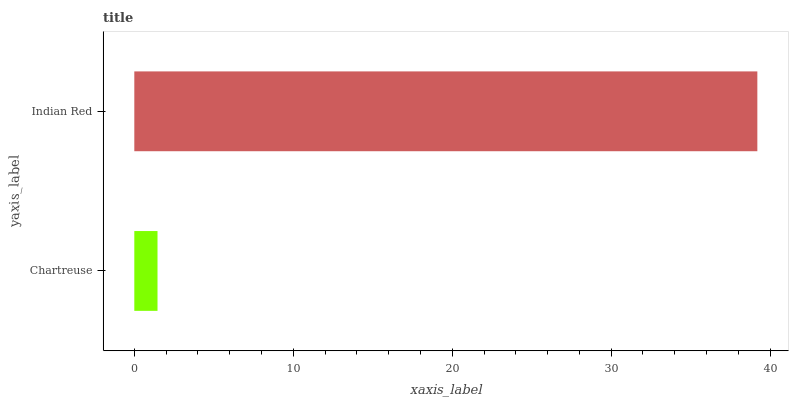Is Chartreuse the minimum?
Answer yes or no. Yes. Is Indian Red the maximum?
Answer yes or no. Yes. Is Indian Red the minimum?
Answer yes or no. No. Is Indian Red greater than Chartreuse?
Answer yes or no. Yes. Is Chartreuse less than Indian Red?
Answer yes or no. Yes. Is Chartreuse greater than Indian Red?
Answer yes or no. No. Is Indian Red less than Chartreuse?
Answer yes or no. No. Is Indian Red the high median?
Answer yes or no. Yes. Is Chartreuse the low median?
Answer yes or no. Yes. Is Chartreuse the high median?
Answer yes or no. No. Is Indian Red the low median?
Answer yes or no. No. 